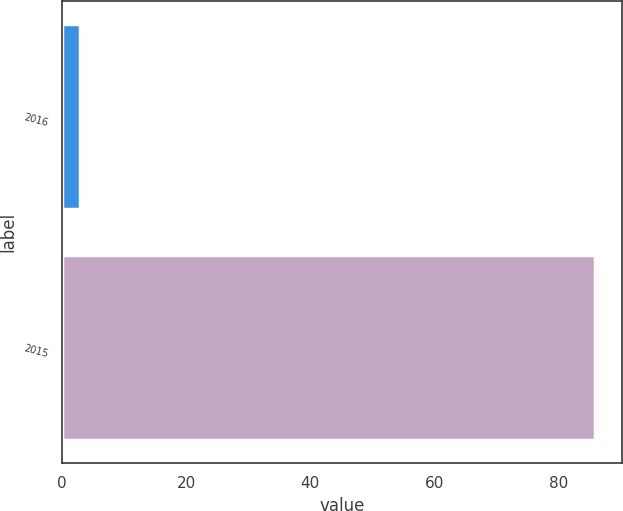Convert chart to OTSL. <chart><loc_0><loc_0><loc_500><loc_500><bar_chart><fcel>2016<fcel>2015<nl><fcel>2.9<fcel>86<nl></chart> 